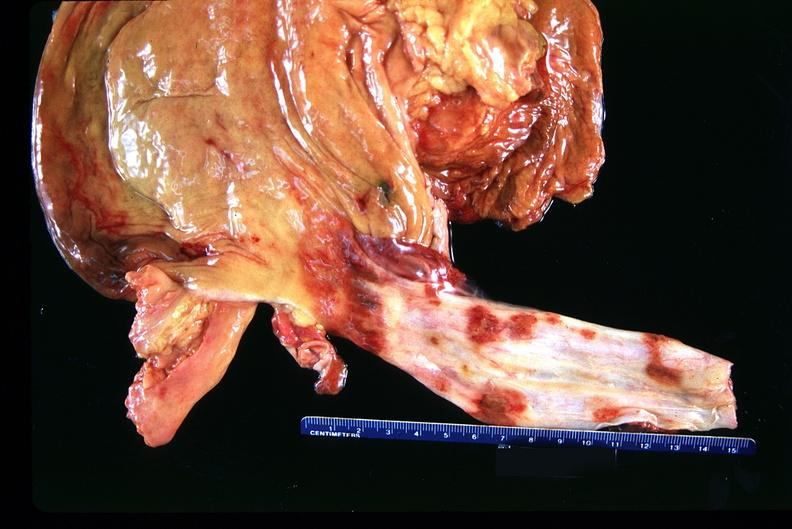what does this image show?
Answer the question using a single word or phrase. Stomach and esophagus 